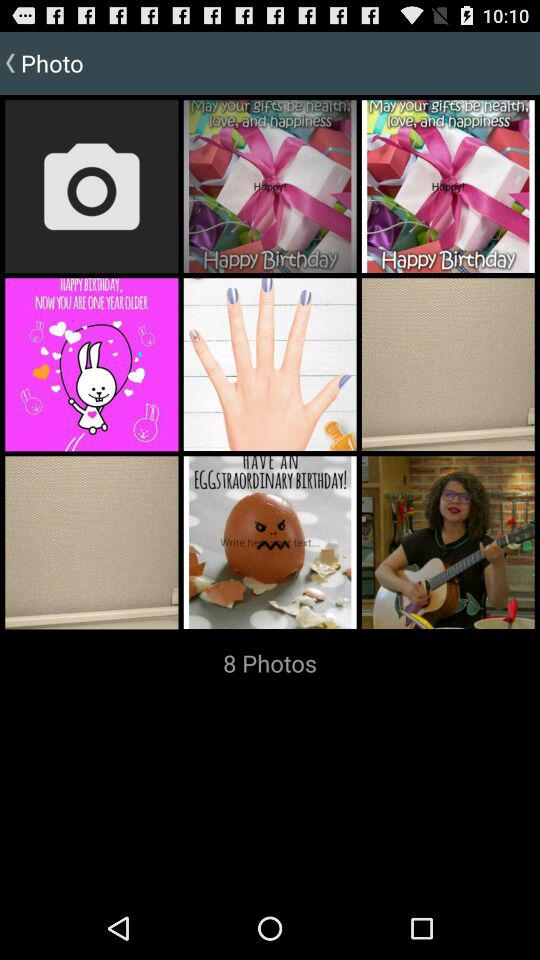What is the total number of photos? The total number of photos is 8. 